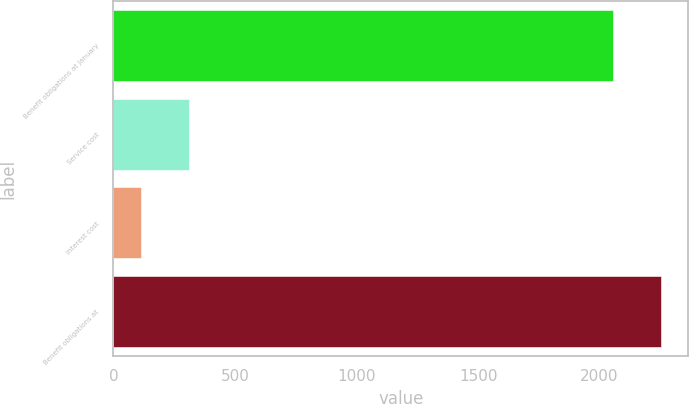<chart> <loc_0><loc_0><loc_500><loc_500><bar_chart><fcel>Benefit obligations at January<fcel>Service cost<fcel>Interest cost<fcel>Benefit obligations at<nl><fcel>2055<fcel>309.4<fcel>113<fcel>2251.4<nl></chart> 